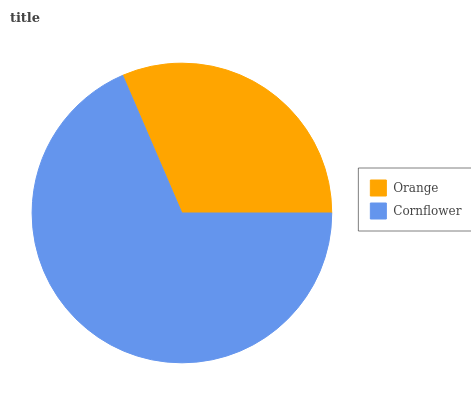Is Orange the minimum?
Answer yes or no. Yes. Is Cornflower the maximum?
Answer yes or no. Yes. Is Cornflower the minimum?
Answer yes or no. No. Is Cornflower greater than Orange?
Answer yes or no. Yes. Is Orange less than Cornflower?
Answer yes or no. Yes. Is Orange greater than Cornflower?
Answer yes or no. No. Is Cornflower less than Orange?
Answer yes or no. No. Is Cornflower the high median?
Answer yes or no. Yes. Is Orange the low median?
Answer yes or no. Yes. Is Orange the high median?
Answer yes or no. No. Is Cornflower the low median?
Answer yes or no. No. 